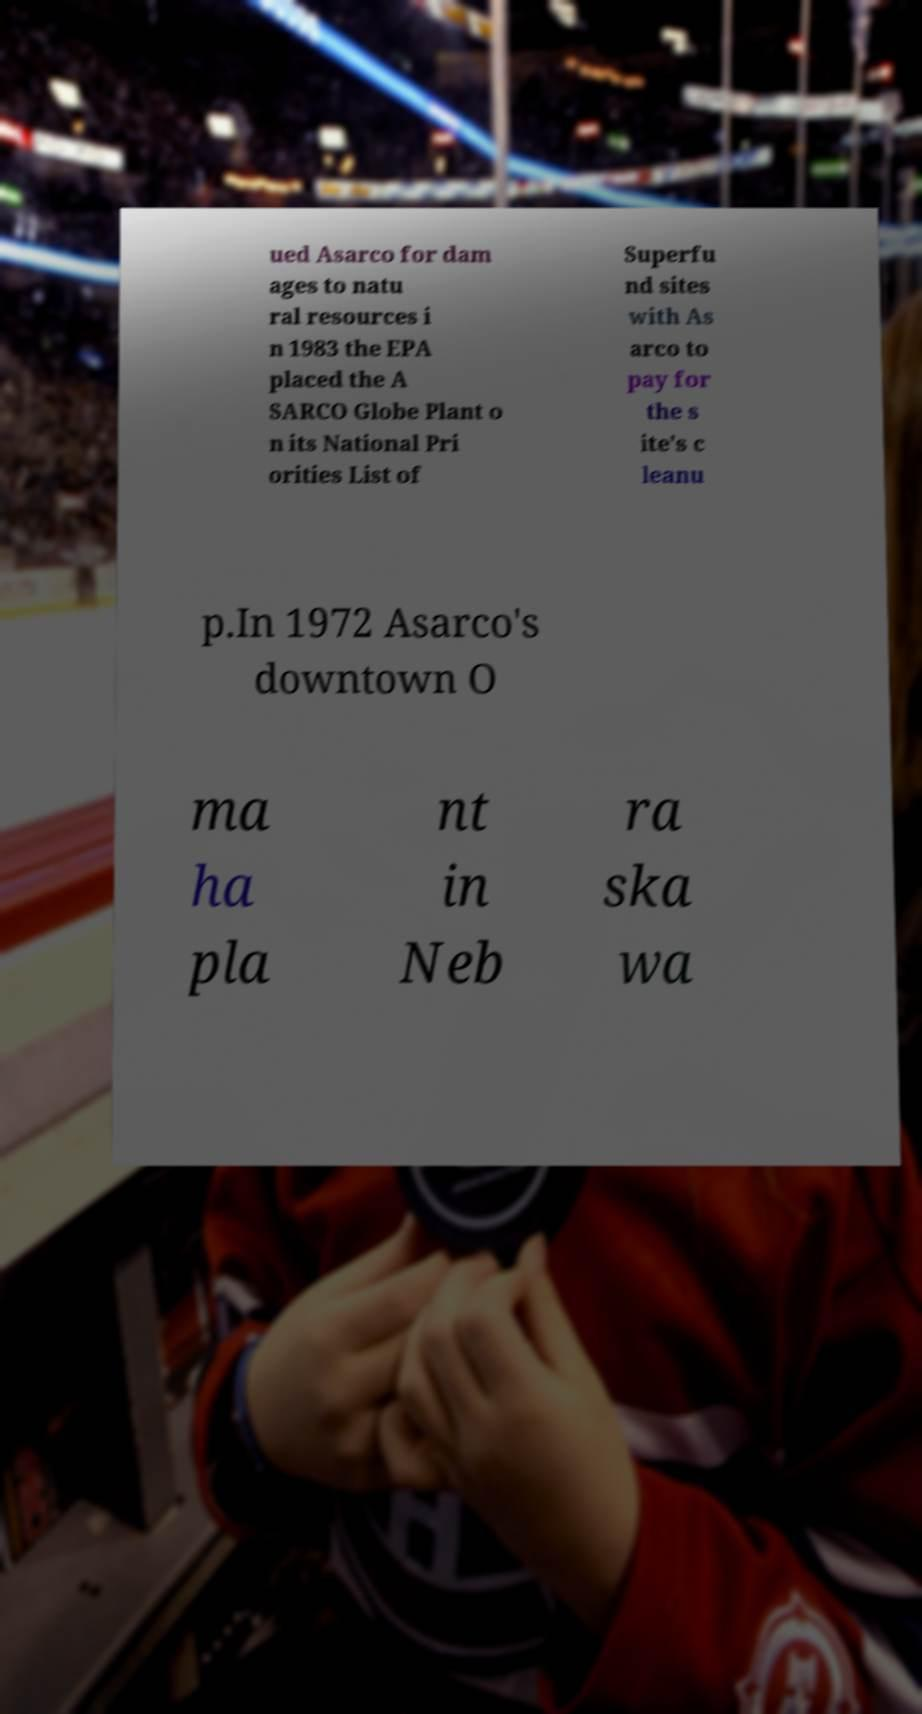Can you accurately transcribe the text from the provided image for me? ued Asarco for dam ages to natu ral resources i n 1983 the EPA placed the A SARCO Globe Plant o n its National Pri orities List of Superfu nd sites with As arco to pay for the s ite's c leanu p.In 1972 Asarco's downtown O ma ha pla nt in Neb ra ska wa 